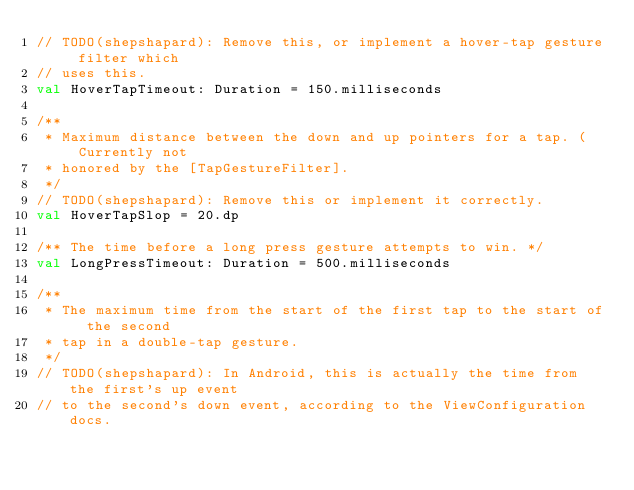<code> <loc_0><loc_0><loc_500><loc_500><_Kotlin_>// TODO(shepshapard): Remove this, or implement a hover-tap gesture filter which
// uses this.
val HoverTapTimeout: Duration = 150.milliseconds

/**
 * Maximum distance between the down and up pointers for a tap. (Currently not
 * honored by the [TapGestureFilter].
 */
// TODO(shepshapard): Remove this or implement it correctly.
val HoverTapSlop = 20.dp

/** The time before a long press gesture attempts to win. */
val LongPressTimeout: Duration = 500.milliseconds

/**
 * The maximum time from the start of the first tap to the start of the second
 * tap in a double-tap gesture.
 */
// TODO(shepshapard): In Android, this is actually the time from the first's up event
// to the second's down event, according to the ViewConfiguration docs.</code> 